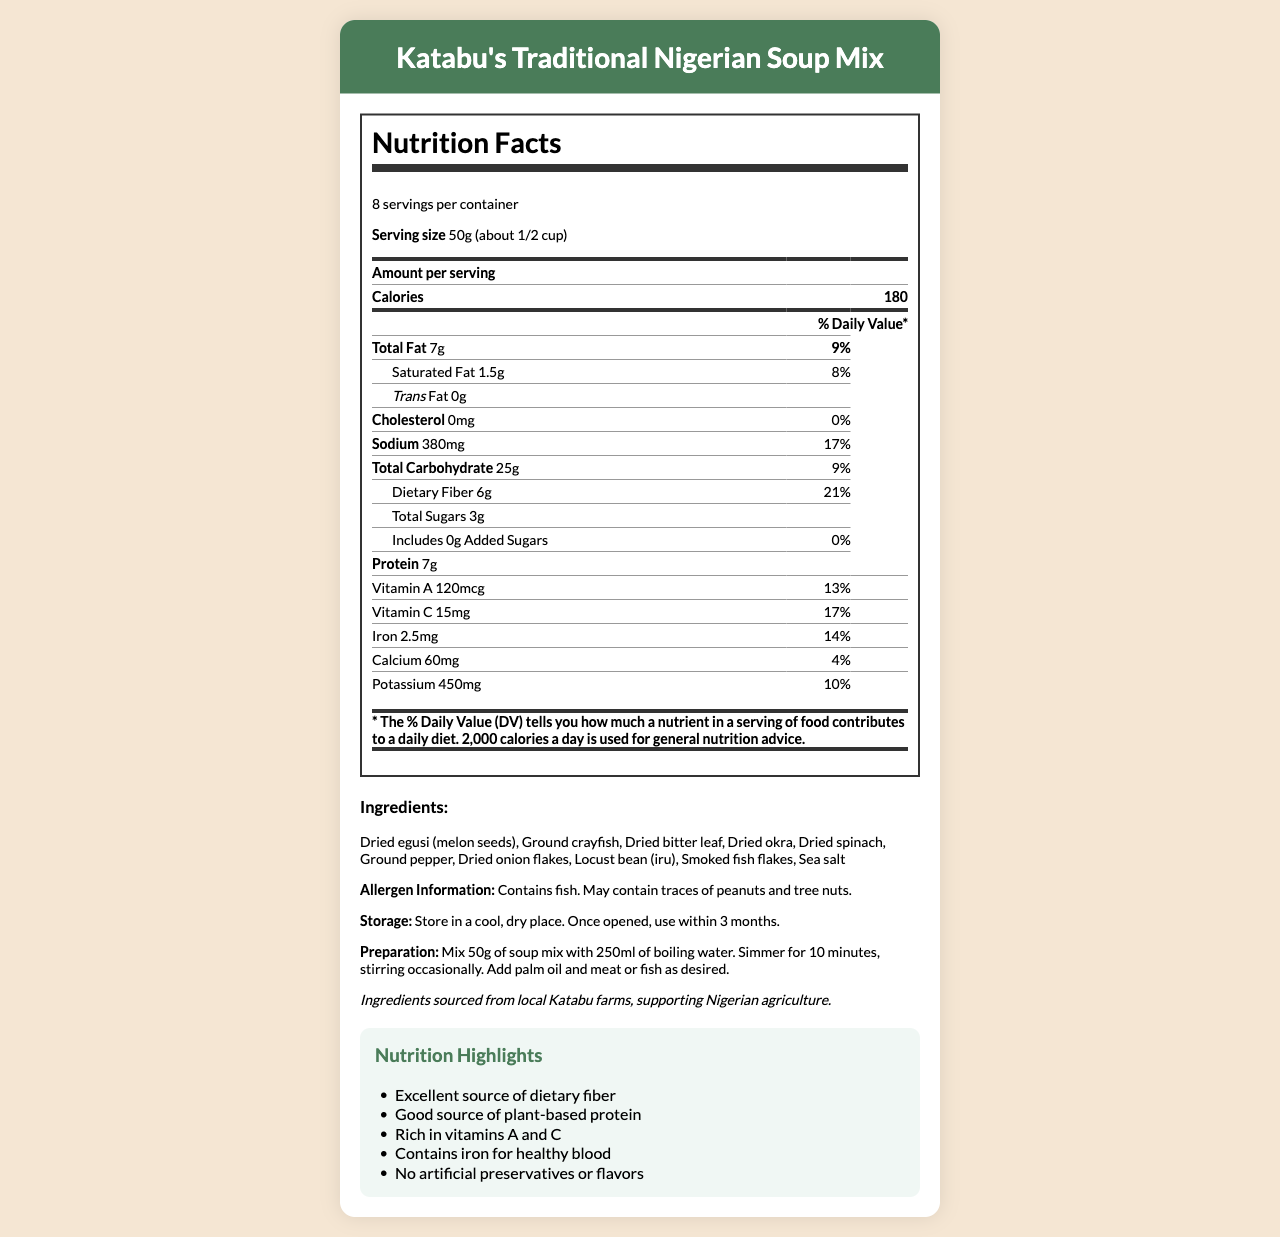what is the serving size of Katabu's Traditional Nigerian Soup Mix? The serving size is mentioned at the top of the nutrition facts table as "Serving size 50g (about 1/2 cup)."
Answer: 50g (about 1/2 cup) how many calories are there per serving? The calories per serving are clearly listed in the nutrition facts section as 180.
Answer: 180 what is the total fat content per serving and its daily value percentage? The nutrition facts show "Total Fat 7g" with a daily value of "9%."
Answer: 7g, 9% how much dietary fiber is in one serving? The dietary fiber amount per serving is listed as "Dietary Fiber 6g" in the nutrition facts.
Answer: 6g does the soup mix contain any added sugars? The nutrition facts explicitly state “Includes 0g Added Sugars” with "0%" daily value.
Answer: No what is the allergen information for the soup mix? The allergen information is provided under the ingredients list and specifies "Contains fish. May contain traces of peanuts and tree nuts."
Answer: Contains fish. May contain traces of peanuts and tree nuts. what are the vitamins and minerals available in Katabu's Traditional Nigerian Soup Mix? The nutrition facts table includes Vitamin A, Vitamin C, Iron, Calcium, and Potassium with their respective amounts and daily values.
Answer: Vitamin A, Vitamin C, Iron, Calcium, Potassium what is the suggested serving preparation for the soup mix? The preparation instructions are specified under the ingredients section as "Mix 50g of soup mix with 250ml of boiling water. Simmer for 10 minutes, stirring occasionally. Add palm oil and meat or fish as desired."
Answer: Mix 50g of soup mix with 250ml of boiling water. Simmer for 10 minutes, stirring occasionally. Add palm oil and meat or fish as desired. which nutrient has the highest daily value percentage per serving?
A. Total Fat
B. Sodium
C. Dietary Fiber
D. Iron The highest daily value percentage listed is for Dietary Fiber at 21%.
Answer: C. Dietary Fiber how many servings are there per container of Katabu's Traditional Nigerian Soup Mix?
1. 6 servings
2. 8 servings
3. 10 servings
4. 12 servings The servings per container are listed at the top of the nutrition facts table as 8.
Answer: 2. 8 servings does Katabu's Traditional Nigerian Soup Mix contain any cholesterol? The nutrition facts state “Cholesterol 0mg” with "0%" daily value.
Answer: No describe the main nutritional highlights of Katabu's Traditional Nigerian Soup Mix. The nutrition highlights are summarized in a separate section, indicating the soup mix's beneficial aspects.
Answer: The main nutritional highlights include it being an excellent source of dietary fiber, a good source of plant-based protein, rich in vitamins A and C, contains iron for healthy blood, and there are no artificial preservatives or flavors. why is iron important for health? The document does not provide information on why iron is important for health.
Answer: I don't know what is the sustainability note mentioned in the document? The sustainability note is provided at the bottom of the ingredients section and states that the ingredients are sourced locally from Katabu farms, supporting Nigerian agriculture.
Answer: Ingredients sourced from local Katabu farms, supporting Nigerian agriculture. 